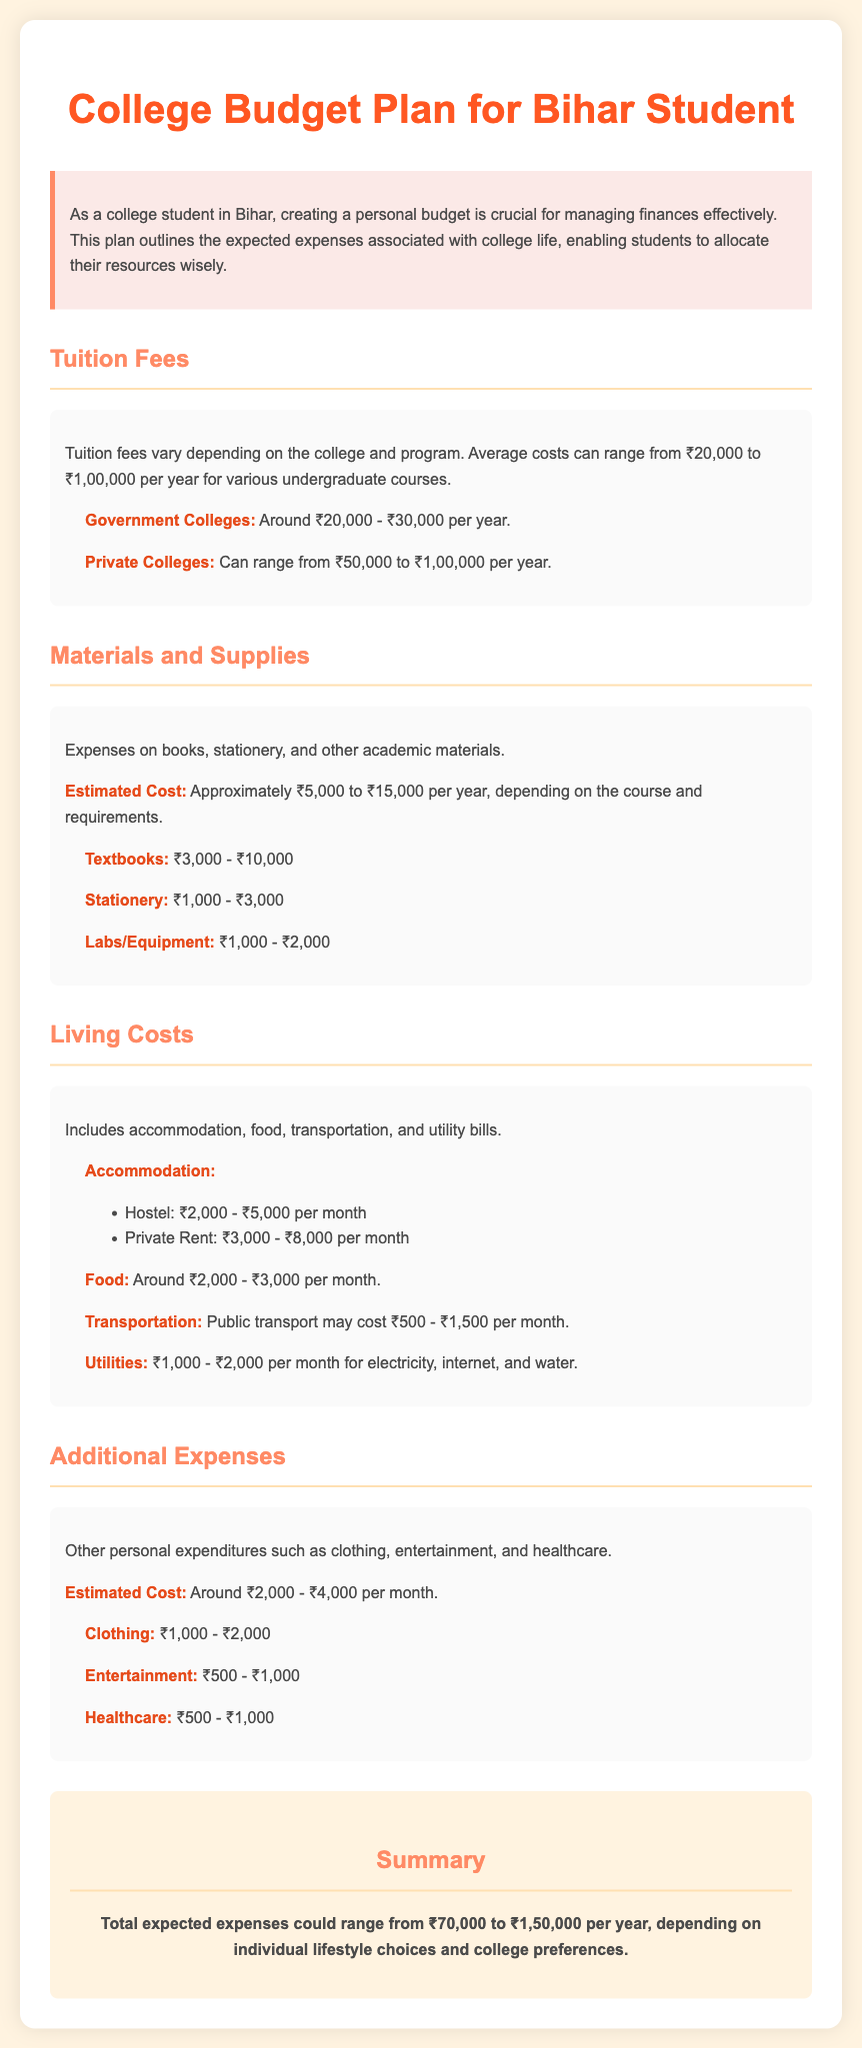What is the average tuition fee range for government colleges? The document states that the average tuition fees for government colleges range from ₹20,000 to ₹30,000 per year.
Answer: ₹20,000 - ₹30,000 What are the estimated living costs per month? The document provides accommodation, food, transportation, and utilities as part of living costs, indicating that it could range from ₹5,500 to ₹13,500 per month.
Answer: ₹5,500 - ₹13,500 What is the estimated cost for textbooks? The document specifically mentions that the estimated cost for textbooks is between ₹3,000 to ₹10,000.
Answer: ₹3,000 - ₹10,000 How much can students expect to spend on additional expenses per month? Additional expenses are projected to be around ₹2,000 to ₹4,000 per month according to the document.
Answer: ₹2,000 - ₹4,000 What is the total expected annual expense range for a college student? The document summarizes that total expected expenses could range from ₹70,000 to ₹1,50,000 per year.
Answer: ₹70,000 - ₹1,50,000 What is the cost range for accommodation in a hostel? The document states that hostel accommodation costs between ₹2,000 to ₹5,000 per month.
Answer: ₹2,000 - ₹5,000 Which type of college generally has higher tuition fees? The document indicates that private colleges generally have higher tuition fees compared to government colleges.
Answer: Private Colleges How much might transportation cost per month? The document suggests that public transportation may cost between ₹500 and ₹1,500 per month.
Answer: ₹500 - ₹1,500 What is the color of the heading in the document? The heading color specified in the document is a bright orange shade identified by the hexadecimal code #FF5722.
Answer: #FF5722 